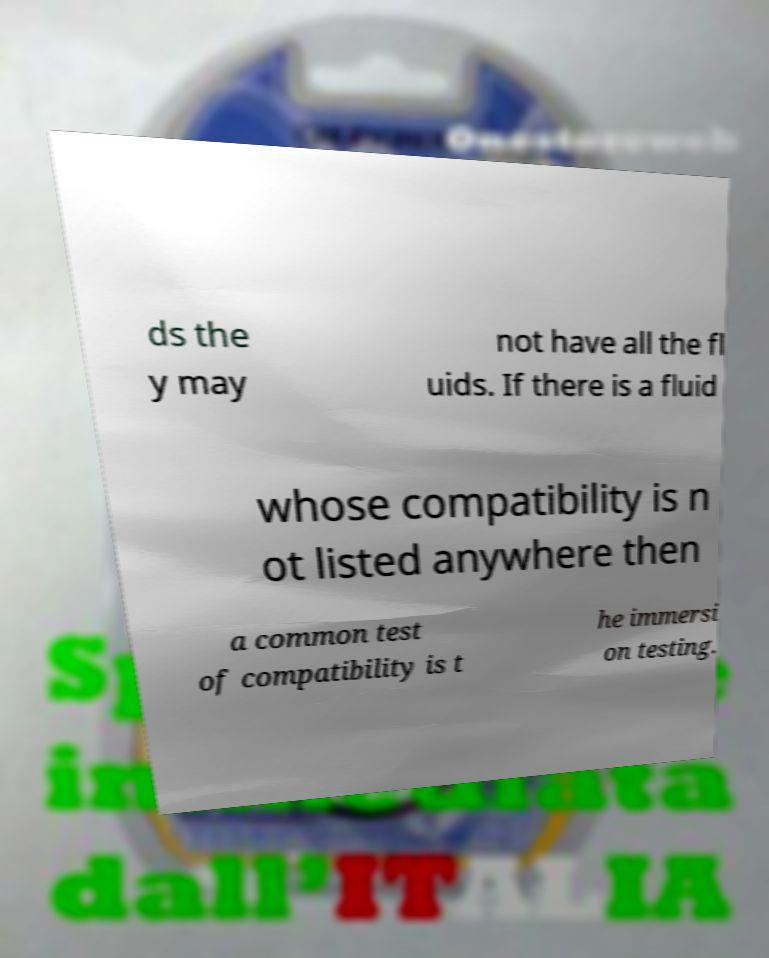I need the written content from this picture converted into text. Can you do that? ds the y may not have all the fl uids. If there is a fluid whose compatibility is n ot listed anywhere then a common test of compatibility is t he immersi on testing. 